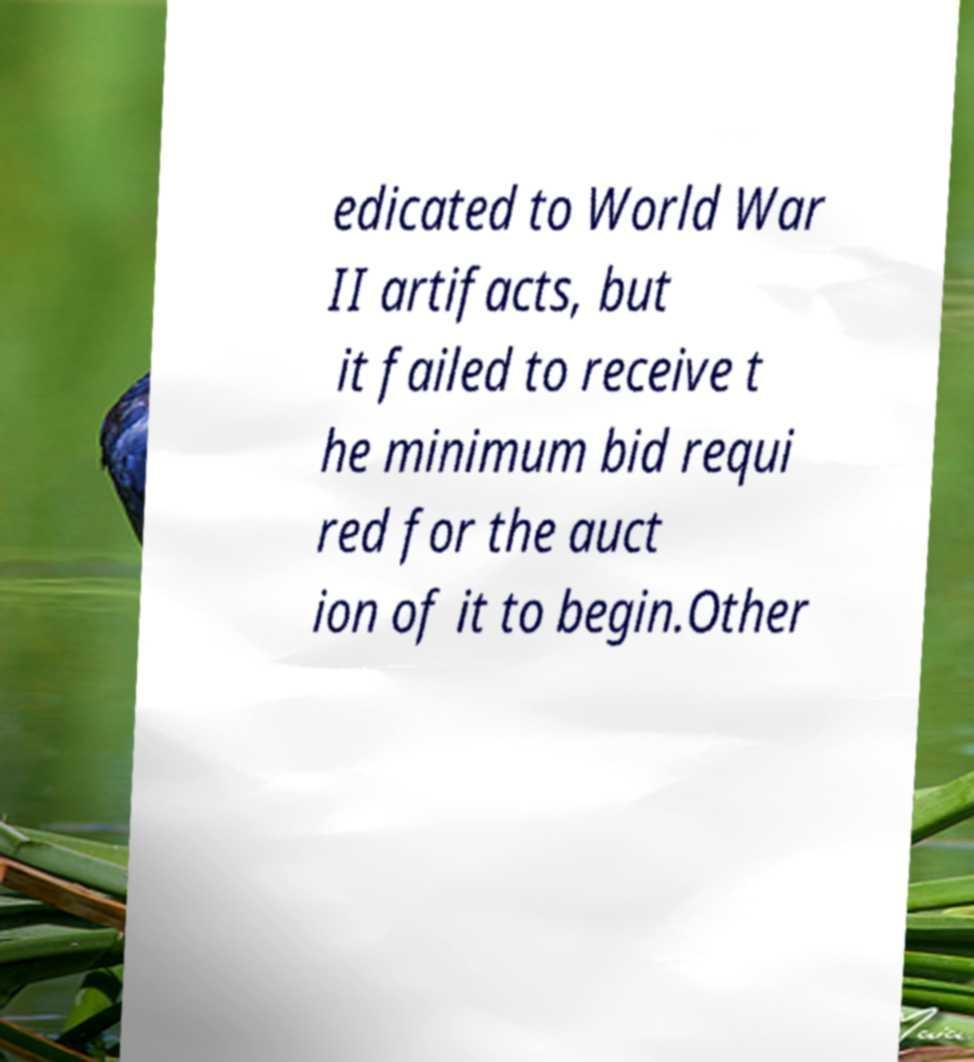Can you read and provide the text displayed in the image?This photo seems to have some interesting text. Can you extract and type it out for me? edicated to World War II artifacts, but it failed to receive t he minimum bid requi red for the auct ion of it to begin.Other 